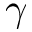<formula> <loc_0><loc_0><loc_500><loc_500>\gamma</formula> 